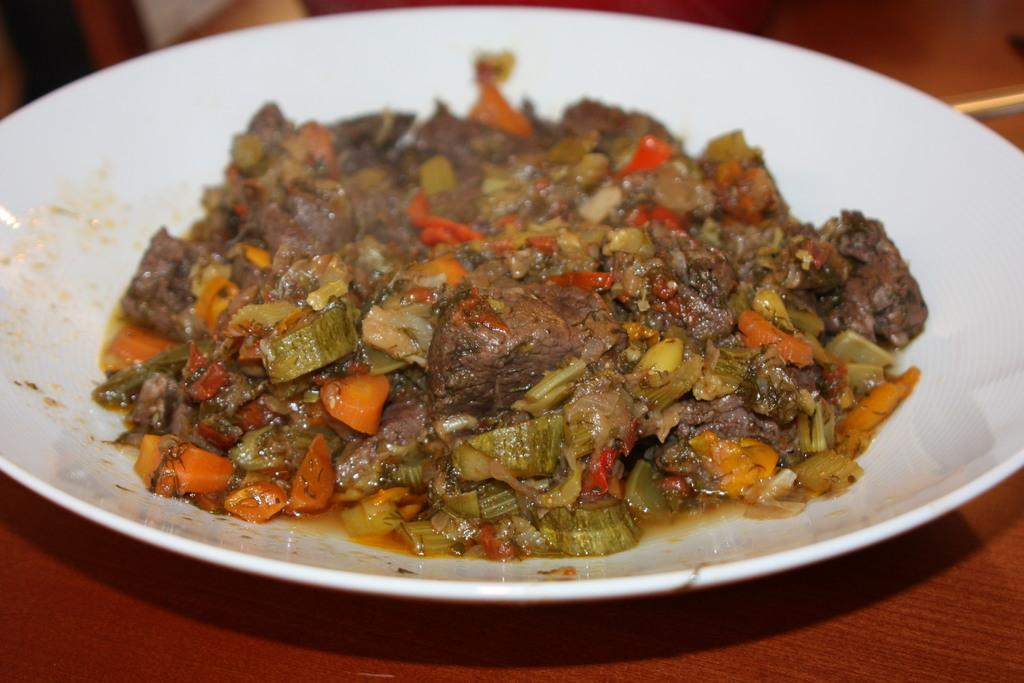What is on the plate that is visible in the image? There is food on a white plate in the image. What is the plate resting on in the image? The plate is on a wooden surface. What can be seen at the top of the image? The top of the image has a blurred view. What type of pen is being used to write on the wooden surface in the image? There is no pen or writing present in the image; it only shows food on a plate and a blurred view at the top. 